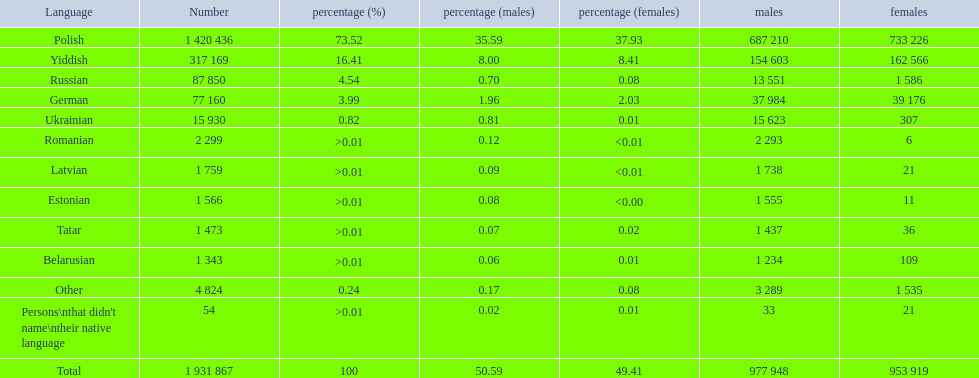What is the percentage of polish speakers? 73.52. What is the next highest percentage of speakers? 16.41. What language is this percentage? Yiddish. Which languages are spoken by more than 50,000 people? Polish, Yiddish, Russian, German. Of these languages, which ones are spoken by less than 15% of the population? Russian, German. Of the remaining two, which one is spoken by 37,984 males? German. Write the full table. {'header': ['Language', 'Number', 'percentage (%)', 'percentage (males)', 'percentage (females)', 'males', 'females'], 'rows': [['Polish', '1 420 436', '73.52', '35.59', '37.93', '687 210', '733 226'], ['Yiddish', '317 169', '16.41', '8.00', '8.41', '154 603', '162 566'], ['Russian', '87 850', '4.54', '0.70', '0.08', '13 551', '1 586'], ['German', '77 160', '3.99', '1.96', '2.03', '37 984', '39 176'], ['Ukrainian', '15 930', '0.82', '0.81', '0.01', '15 623', '307'], ['Romanian', '2 299', '>0.01', '0.12', '<0.01', '2 293', '6'], ['Latvian', '1 759', '>0.01', '0.09', '<0.01', '1 738', '21'], ['Estonian', '1 566', '>0.01', '0.08', '<0.00', '1 555', '11'], ['Tatar', '1 473', '>0.01', '0.07', '0.02', '1 437', '36'], ['Belarusian', '1 343', '>0.01', '0.06', '0.01', '1 234', '109'], ['Other', '4 824', '0.24', '0.17', '0.08', '3 289', '1 535'], ["Persons\\nthat didn't name\\ntheir native language", '54', '>0.01', '0.02', '0.01', '33', '21'], ['Total', '1 931 867', '100', '50.59', '49.41', '977 948', '953 919']]} 